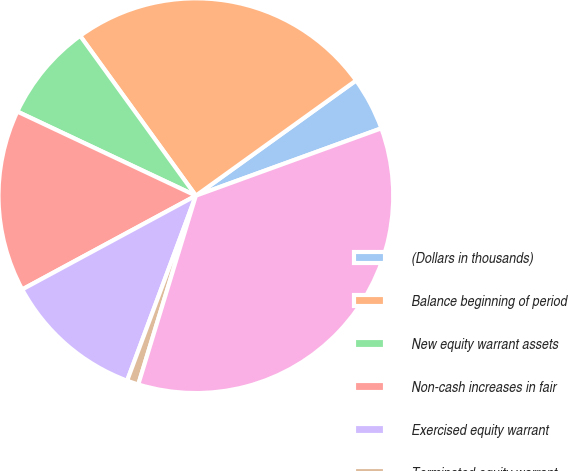<chart> <loc_0><loc_0><loc_500><loc_500><pie_chart><fcel>(Dollars in thousands)<fcel>Balance beginning of period<fcel>New equity warrant assets<fcel>Non-cash increases in fair<fcel>Exercised equity warrant<fcel>Terminated equity warrant<fcel>Balance end of period<nl><fcel>4.38%<fcel>25.05%<fcel>8.02%<fcel>14.89%<fcel>11.46%<fcel>0.95%<fcel>35.26%<nl></chart> 